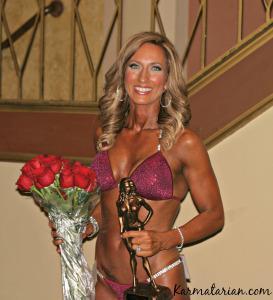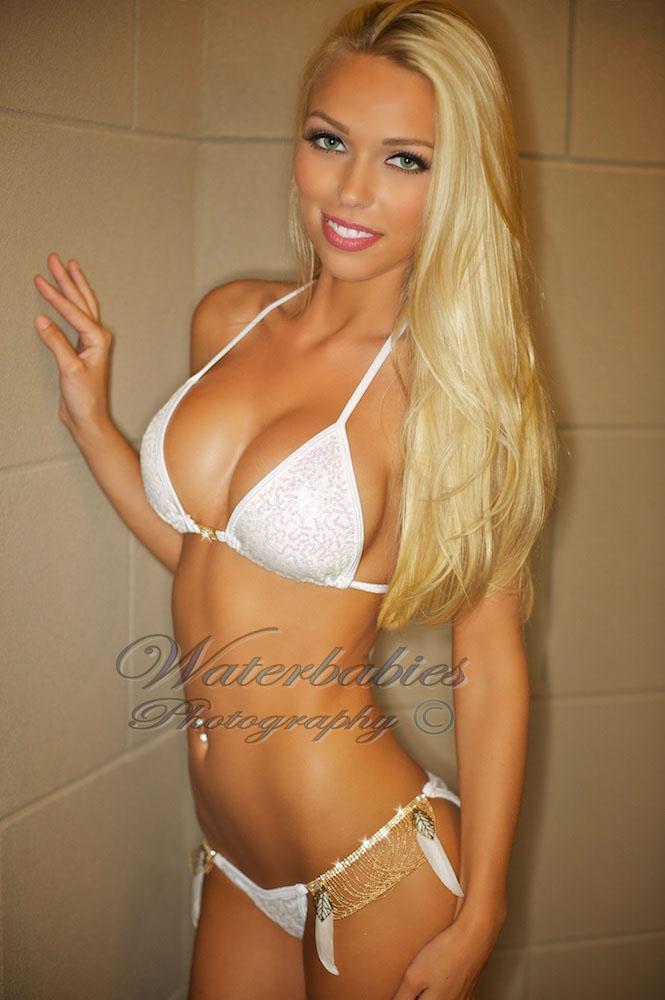The first image is the image on the left, the second image is the image on the right. Assess this claim about the two images: "An image shows a woman wearing a shiny gold bikini and posing with her arm on her hip.". Correct or not? Answer yes or no. No. The first image is the image on the left, the second image is the image on the right. For the images displayed, is the sentence "The left and right image contains the same number of bikinis with one being gold." factually correct? Answer yes or no. No. 